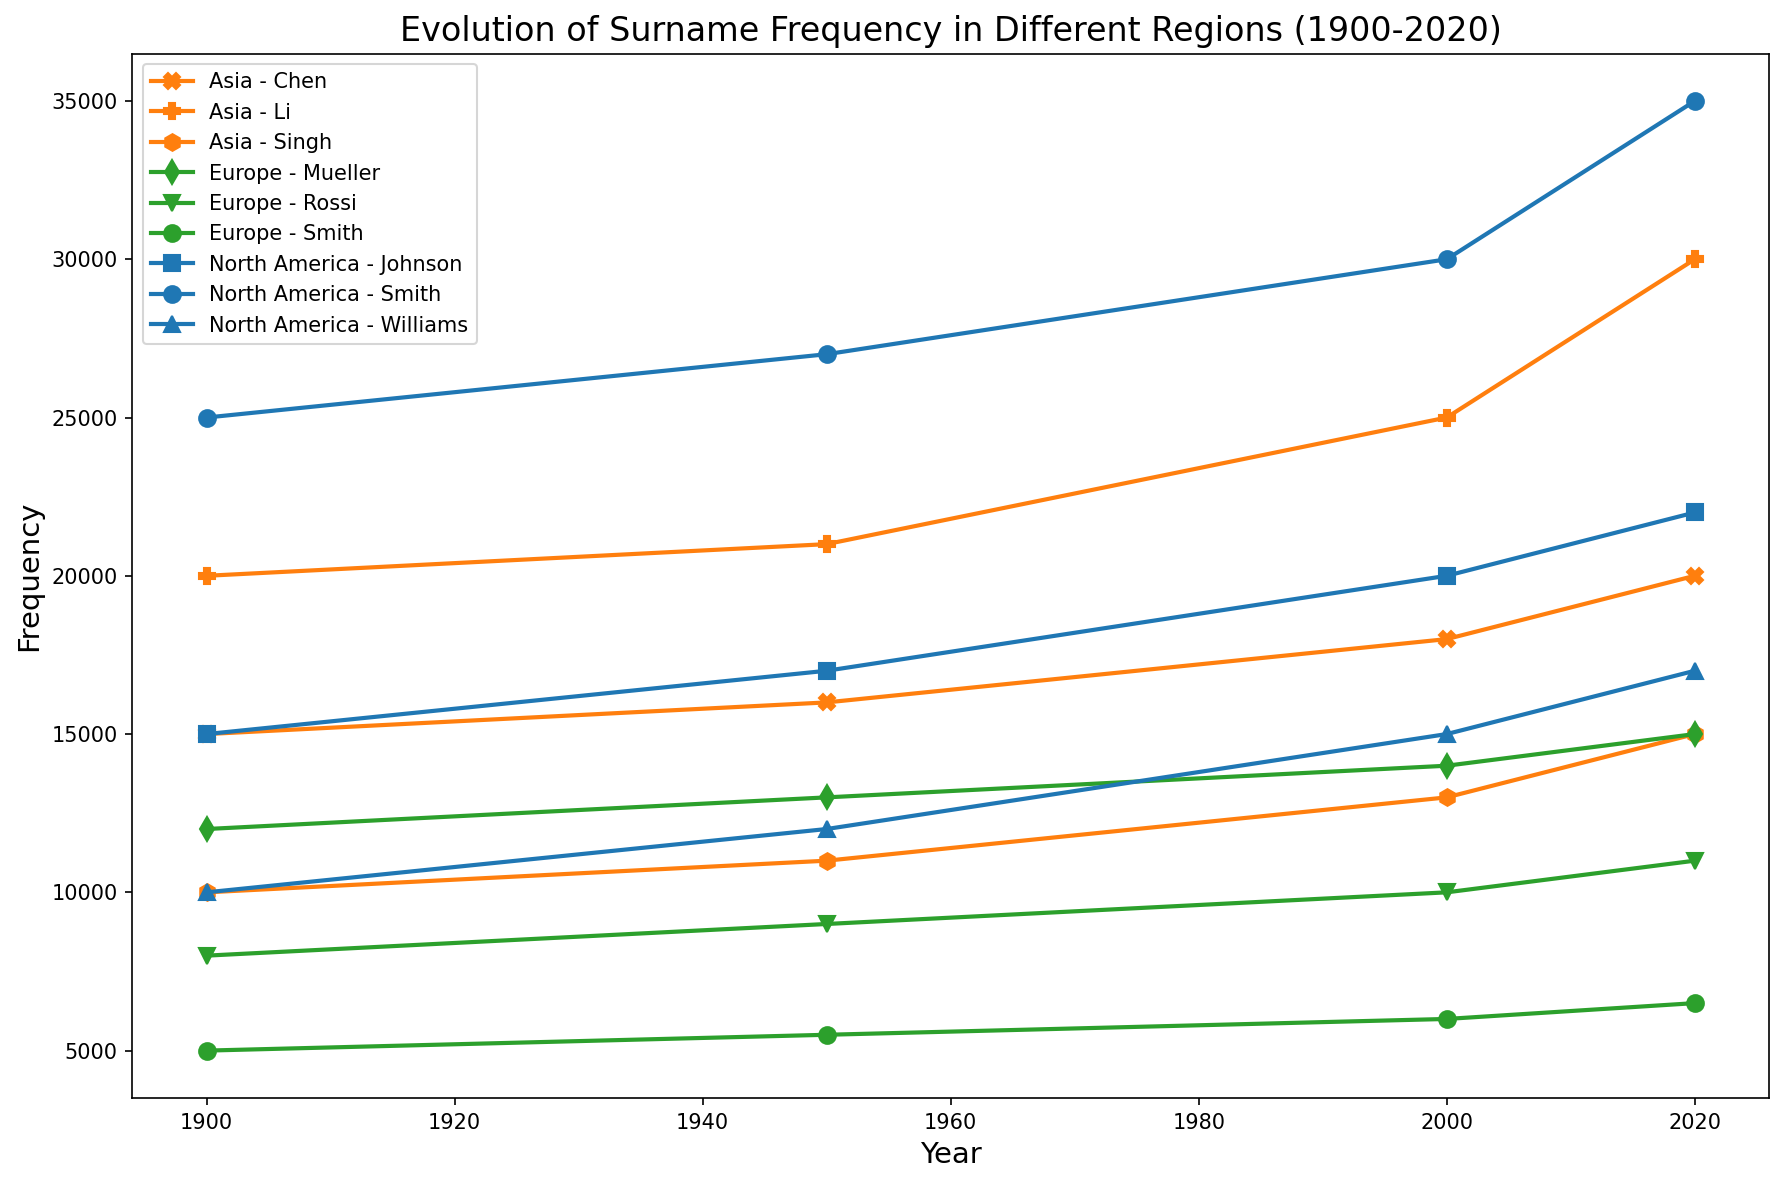Which region has the highest frequency of the surname "Smith" in the year 2020? We need to look at the lines corresponding to "Smith" in each region in the year 2020. North America has 35,000, Europe has 6,500, and Asia has no representation of the surname "Smith". Thus, North America has the highest frequency.
Answer: North America How did the frequency of the surname "Li" in Asia change from 1900 to 2020? To answer this, we need to find the frequency at two points: in 1900, it was 20,000; in 2020, it is 30,000. The frequency increased by 10,000 over these years.
Answer: Increased by 10,000 What is the overall trend in the frequency of the surname "Mueller" in Europe from 1900 to 2020? We must look at the points for "Mueller" in Europe over the years: 12,000 in 1900, 13,000 in 1950, 14,000 in 2000, and 15,000 in 2020. The overall trend is an increase.
Answer: Increasing trend Compare the frequency of the surname "Williams" in North America between 1900 and 2020. In 1900, the frequency was 10,000; by 2020, it had increased to 17,000. To find the change, we subtract the earlier value from the later value: 17,000 - 10,000 = 7,000.
Answer: Increased by 7,000 Which surname in Asia has shown the largest increase in frequency from 1900 to 2020? We need to compare the changes for Li, Chen, and Singh between 1900 and 2020. Li increased from 20,000 to 30,000, an increase of 10,000; Chen from 15,000 to 20,000, an increase of 5,000; Singh from 10,000 to 15,000, an increase of 5,000. So, Li had the largest increase.
Answer: Li In which year did the surname "Rossi" in Europe surpass a frequency of 10,000? We need to look at the years for Rossi in Europe: 8,000 in 1900, 9,000 in 1950, 10,000 in 2000 (reaches exactly 10,000 but not surpassing), and 11,000 in 2020. Therefore, it surpasses 10,000 in 2020.
Answer: 2020 By how much did the frequency of the surname "Chen" in Asia increase between 1950 and 2000? In 1950, the frequency was 16,000; in 2000, it was 18,000. To find the increase, we subtract the earlier value: 18,000 - 16,000 = 2,000.
Answer: 2,000 Compare the frequency of "Johnson" in North America with "Mueller" in Europe in 2020. In 2020, the frequency of "Johnson" in North America is 22,000, while "Mueller" in Europe is 15,000. Therefore, "Johnson" has a higher frequency.
Answer: Johnson Identify the year and surname with the highest frequency in North America. We need to look at all surnames and years for North America. The highest frequency in North America is "Smith" in 2020, with a frequency of 35,000.
Answer: Smith in 2020 